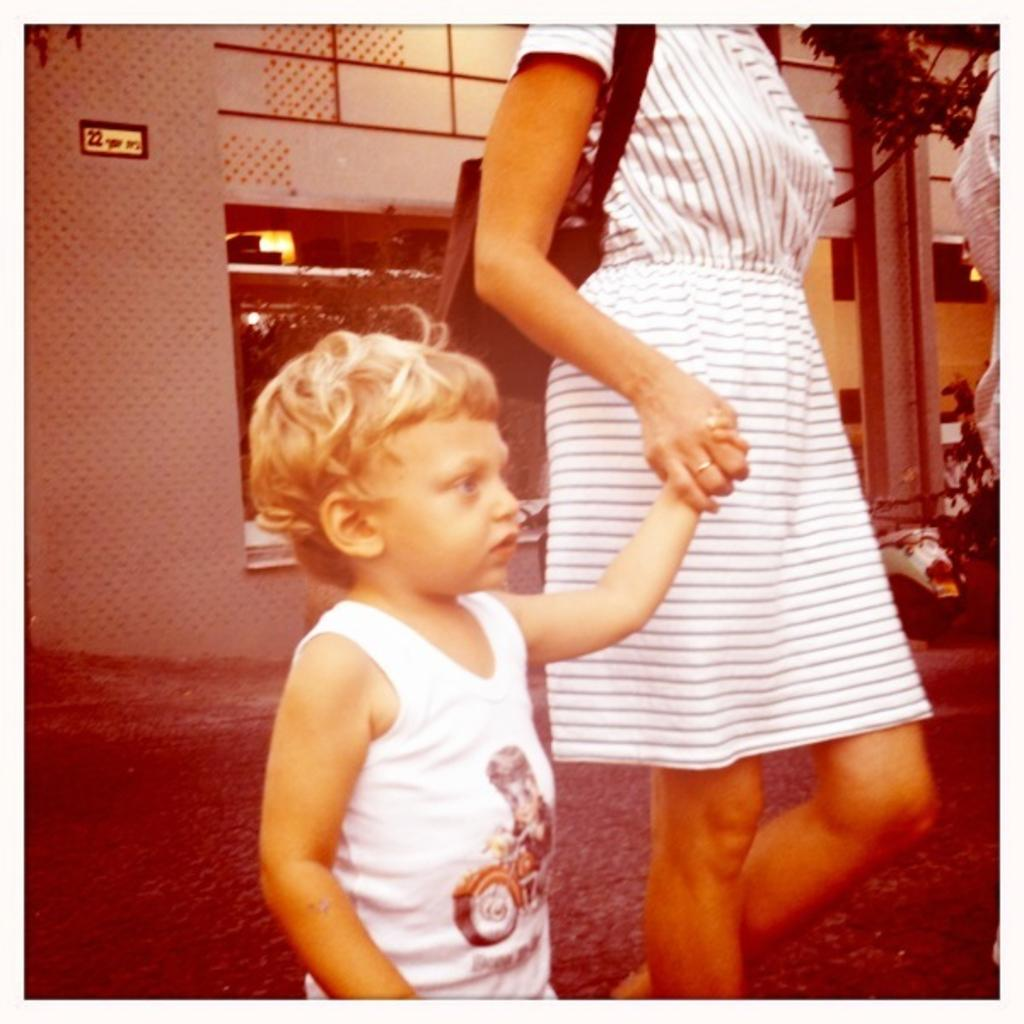Who is the main subject in the image? There is a woman in the image. What is the woman wearing? The woman is wearing a white dress. What is the woman holding in the image? The woman is holding a baby. What is the baby wearing? The baby is wearing a white vest. What are the woman and baby doing in the image? The woman and baby are walking on a road. What can be seen in the background of the image? There is a building in the background of the image. What is present on the right side of the image? There are vehicles in front of the building on the right side. How much sand is visible on the road in the image? There is no sand visible on the road in the image. What type of salt is being used to season the baby's food in the image? There is no salt or food present in the image; the woman is holding a baby. 